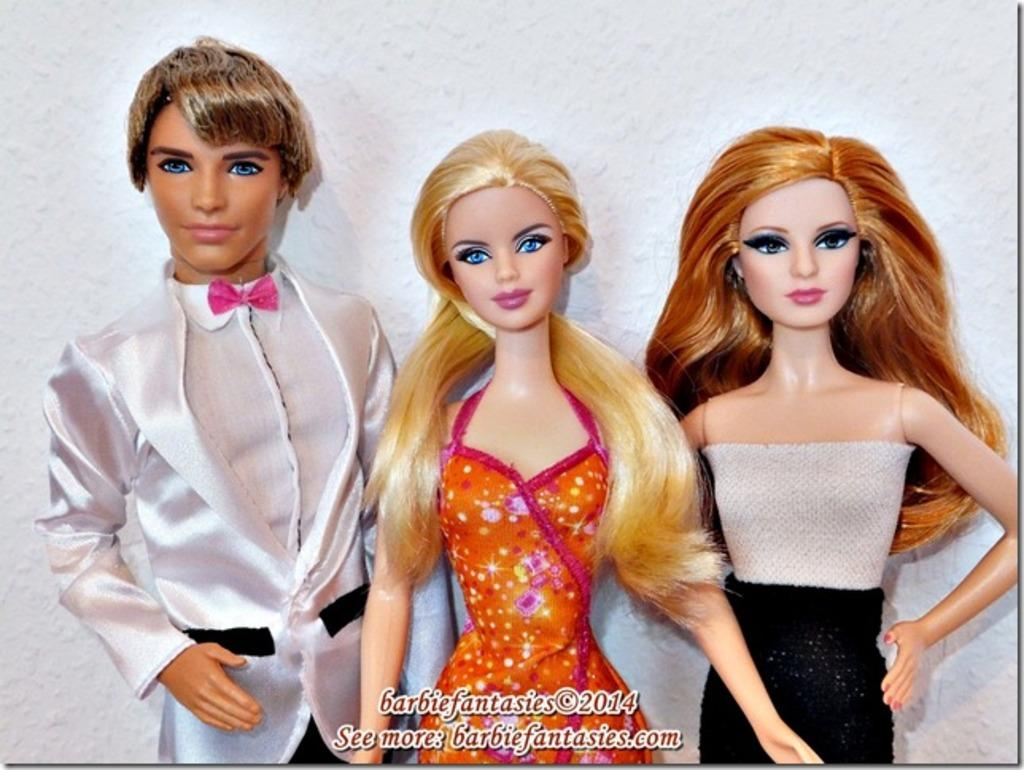How many dolls are present in the image? There are three dolls in the image. What can be seen in the background of the image? There is a wall in the background of the image. Is there any text visible in the image? Yes, there is some text written at the bottom of the image. What type of zephyr is being used to cut the pie in the image? There is no zephyr or pie present in the image. How many needles are visible in the image? There are no needles visible in the image. 